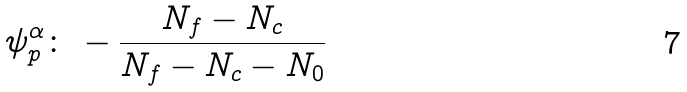<formula> <loc_0><loc_0><loc_500><loc_500>\psi _ { p } ^ { \alpha } \colon \, - \frac { N _ { f } - N _ { c } } { N _ { f } - N _ { c } - N _ { 0 } }</formula> 